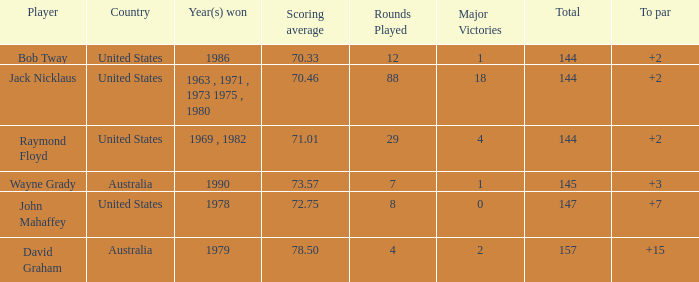How many strokes off par was the winner in 1978? 7.0. Could you parse the entire table? {'header': ['Player', 'Country', 'Year(s) won', 'Scoring average', 'Rounds Played', 'Major Victories', 'Total', 'To par'], 'rows': [['Bob Tway', 'United States', '1986', '70.33', '12', '1', '144', '+2'], ['Jack Nicklaus', 'United States', '1963 , 1971 , 1973 1975 , 1980', '70.46', '88', '18', '144', '+2'], ['Raymond Floyd', 'United States', '1969 , 1982', '71.01', '29', '4', '144', '+2'], ['Wayne Grady', 'Australia', '1990', '73.57', '7', '1', '145', '+3'], ['John Mahaffey', 'United States', '1978', '72.75', '8', '0', '147', '+7'], ['David Graham', 'Australia', '1979', '78.50', '4', '2', '157', '+15']]} 